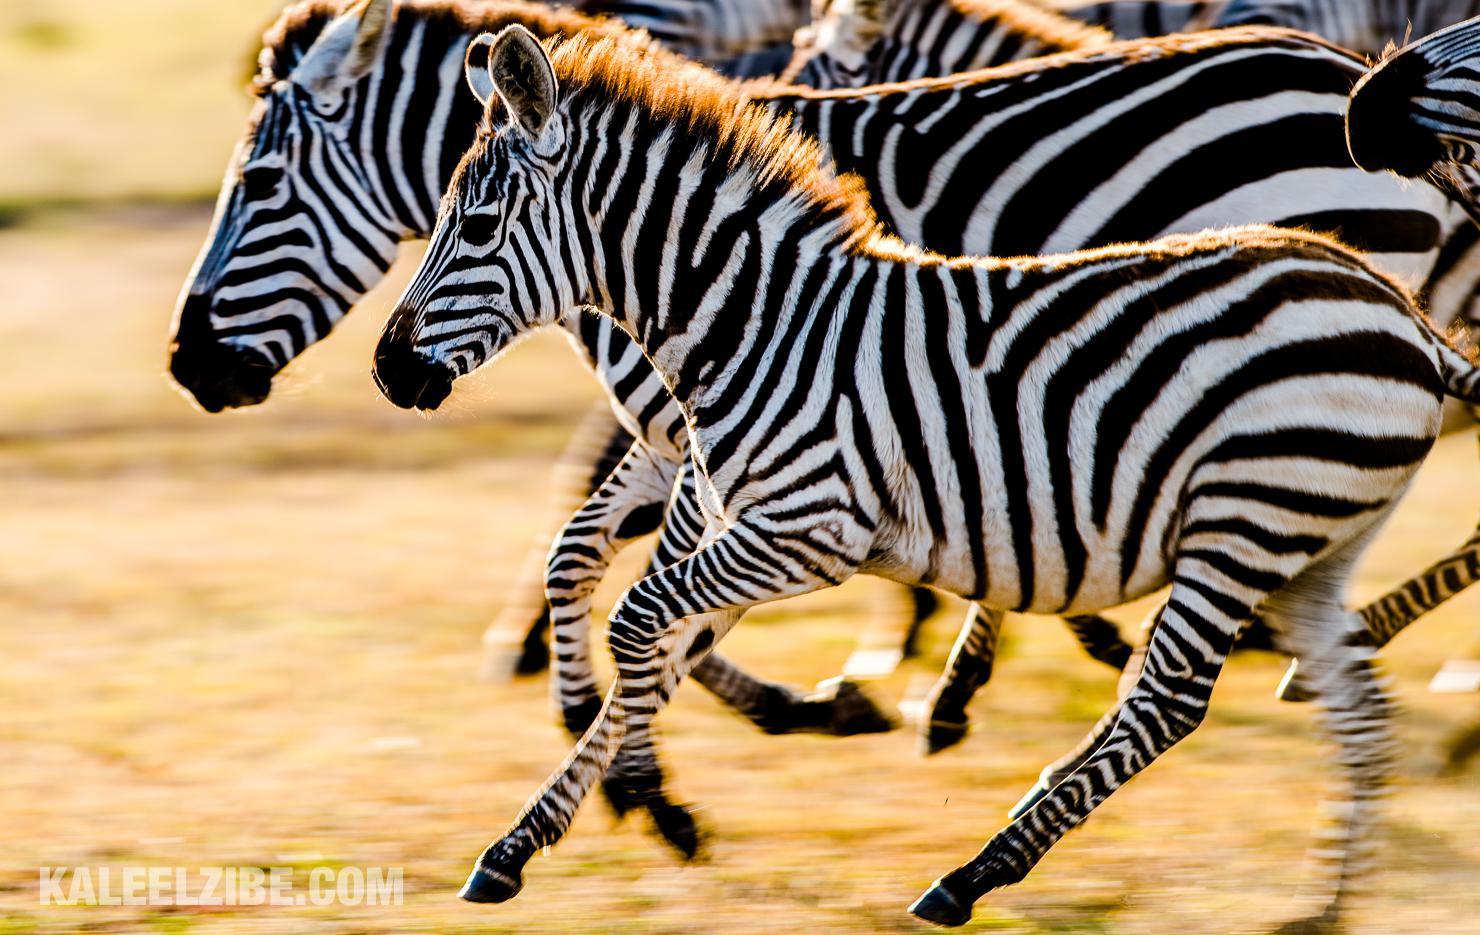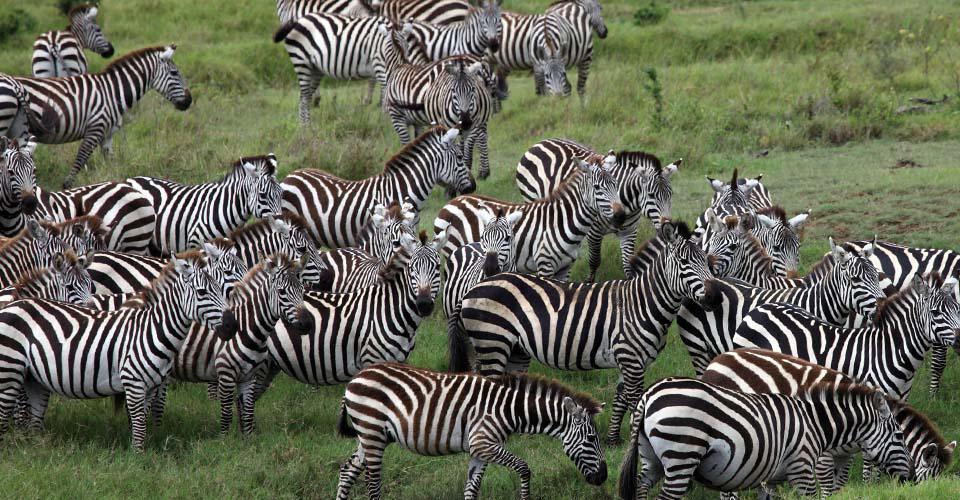The first image is the image on the left, the second image is the image on the right. For the images displayed, is the sentence "One image has a trio of zebras standing with bodies turned forward and gazing straight at the camera, in the foreground." factually correct? Answer yes or no. No. 